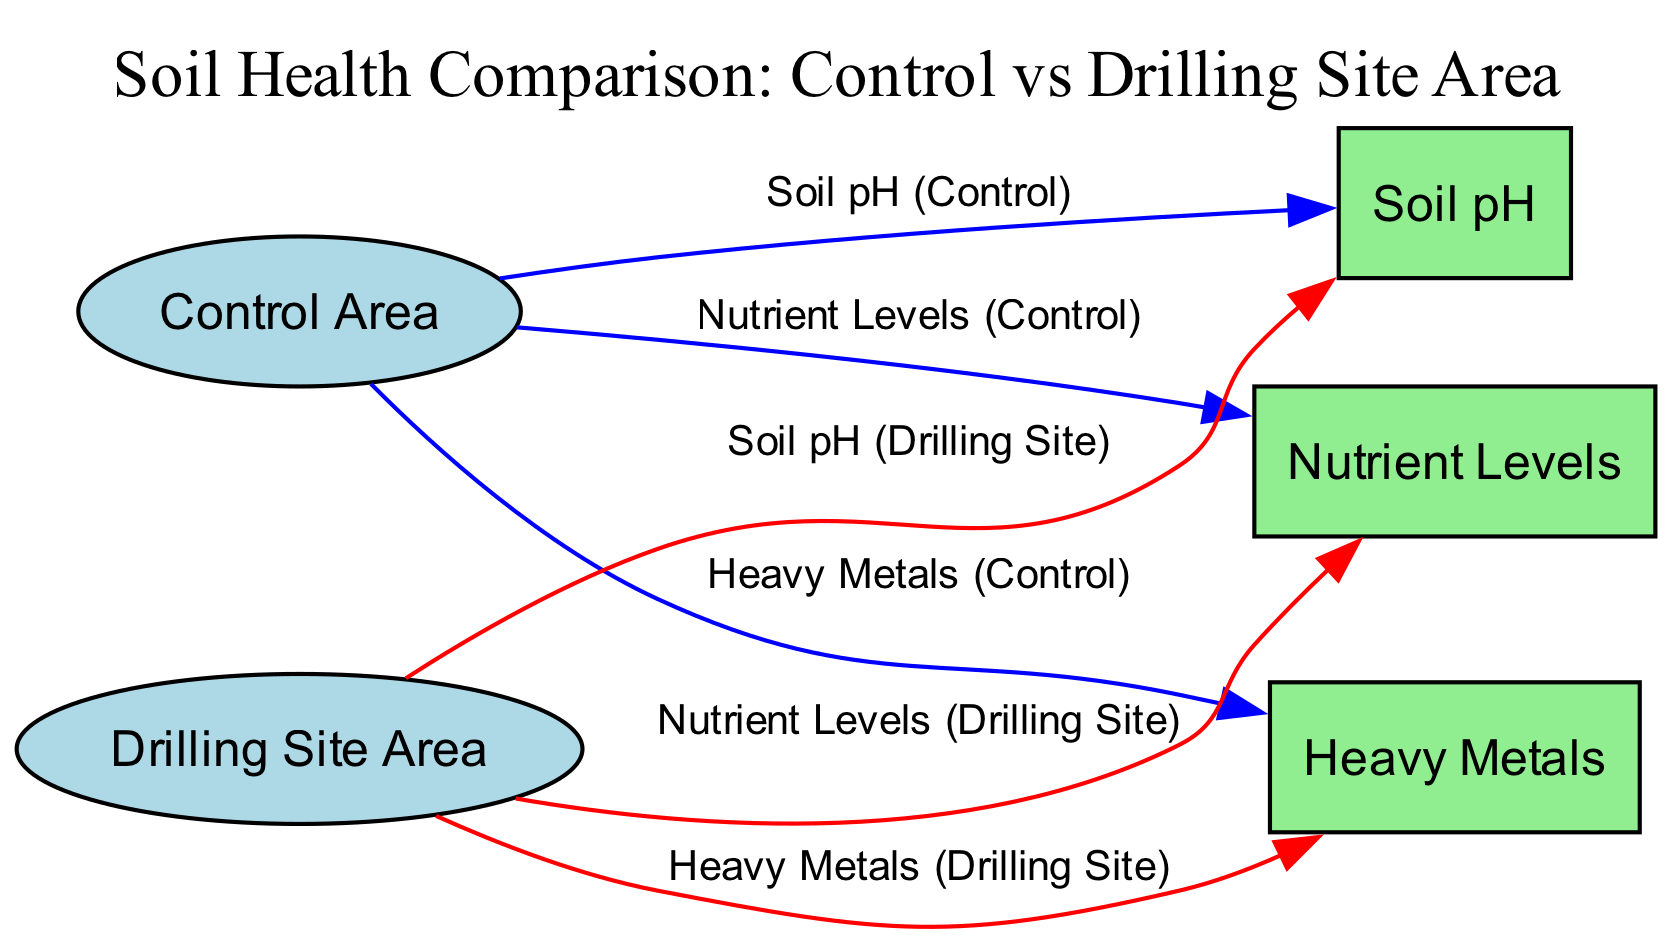What are the parameters compared in the diagram? The diagram compares three parameters: Nutrient Levels, Soil pH, and Heavy Metals. Each of these parameters is analyzed in two areas: the Control Area and the Drilling Site Area.
Answer: Nutrient Levels, Soil pH, and Heavy Metals How many edges are there in the diagram? The diagram has six edges connecting the Control Area and Drilling Site Area to the three parameters. Each parameter has an edge from both areas, resulting in 6 edges total.
Answer: 6 What color represents the edges leading from the Control Area? The edges leading from the Control Area are colored blue, which signifies the comparison of the Control Area's parameters against the Drilling Site Area.
Answer: Blue Which area shows potentially higher Heavy Metals presence? The Drilling Site Area shows potentially higher Heavy Metals presence, as indicated by the red edges leading from this area to the Heavy Metals node, suggesting a comparison to the Control Area.
Answer: Drilling Site Area What type of soil is represented in this diagram? The diagram discusses soil health components like nutrient levels, pH, and heavy metals, which pertain to general soil rather than a specific type. Therefore, it focuses on soil health parameters rather than a particular soil type.
Answer: Soil Health Which parameter has been analyzed for both areas? Each of the three parameters—Nutrient Levels, Soil pH, and Heavy Metals—has been analyzed for both the Control Area and the Drilling Site Area, evidenced by the connections shown in the diagram.
Answer: All parameters What does the label “Heavy Metals (Control)” imply? The label “Heavy Metals (Control)” implies that this edge represents the measurement of heavy metal contamination in the Control Area, serving as a baseline for comparison against the Drilling Site Area.
Answer: Measurement of heavy metals in the Control Area Which node connects to the most edges in the diagram? All parameters connect to two edges each—one from the Control Area and one from the Drilling Site Area—so every parameter node (Nutrient Levels, Soil pH, Heavy Metals) connects to the same number of edges.
Answer: Equal connections for all parameters 